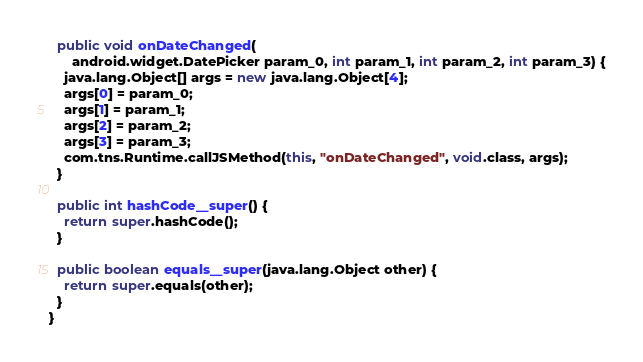Convert code to text. <code><loc_0><loc_0><loc_500><loc_500><_Java_>  public void onDateChanged(
      android.widget.DatePicker param_0, int param_1, int param_2, int param_3) {
    java.lang.Object[] args = new java.lang.Object[4];
    args[0] = param_0;
    args[1] = param_1;
    args[2] = param_2;
    args[3] = param_3;
    com.tns.Runtime.callJSMethod(this, "onDateChanged", void.class, args);
  }

  public int hashCode__super() {
    return super.hashCode();
  }

  public boolean equals__super(java.lang.Object other) {
    return super.equals(other);
  }
}
</code> 